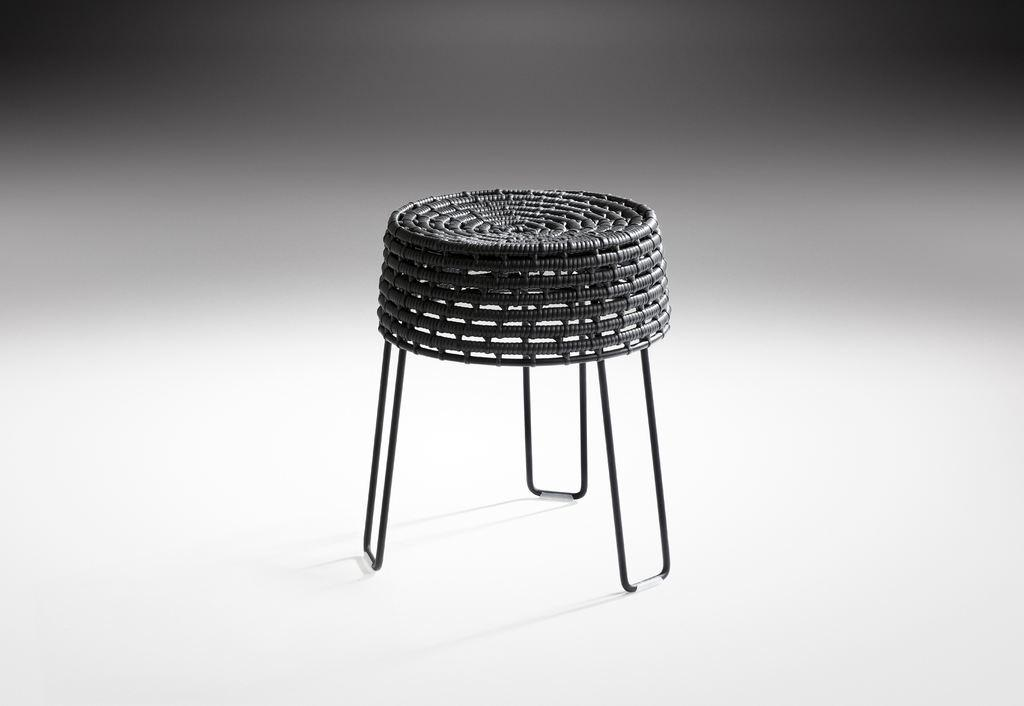What can be inferred about the location of the image? The image was likely taken indoors. What type of furniture is present in the image? There is a black color stool in the image. What is the stool placed on? The stool is placed on a white color object, which appears to be the ground. Is the brain visible in the image? No, the brain is not visible in the image. What is the temperature of the stool in the image? The temperature of the stool cannot be determined from the image. 